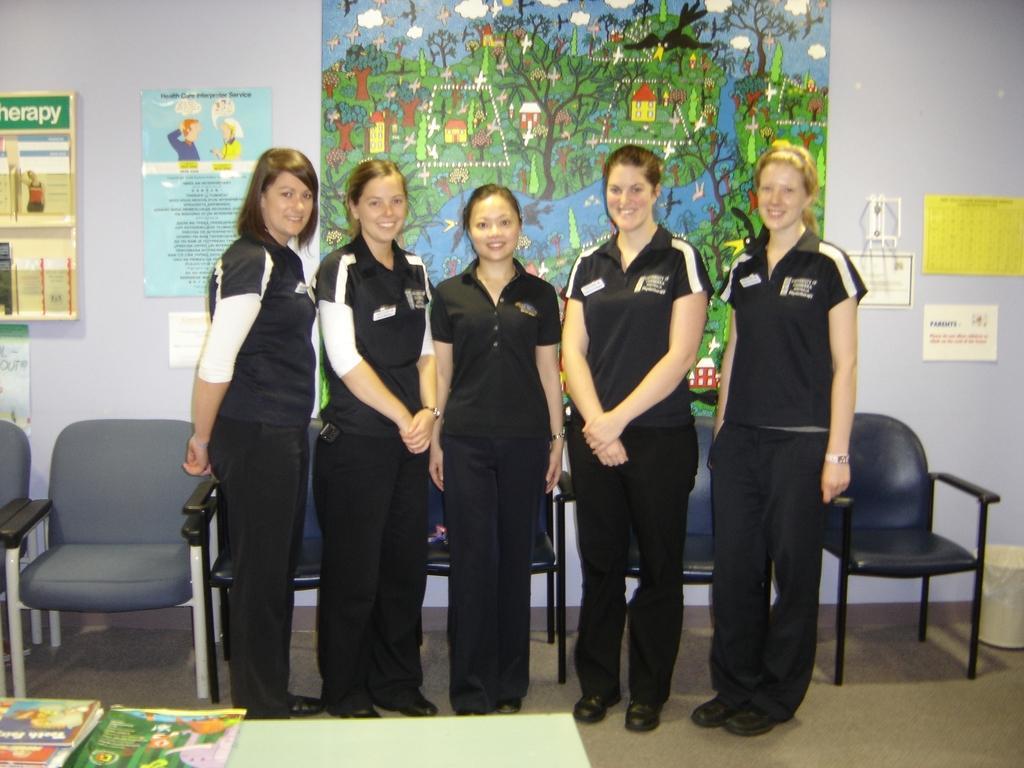Please provide a concise description of this image. In this image i can see five women standing and laughing there are few books in front the woman at the background i can see chairs and a paper attached to a wall. 